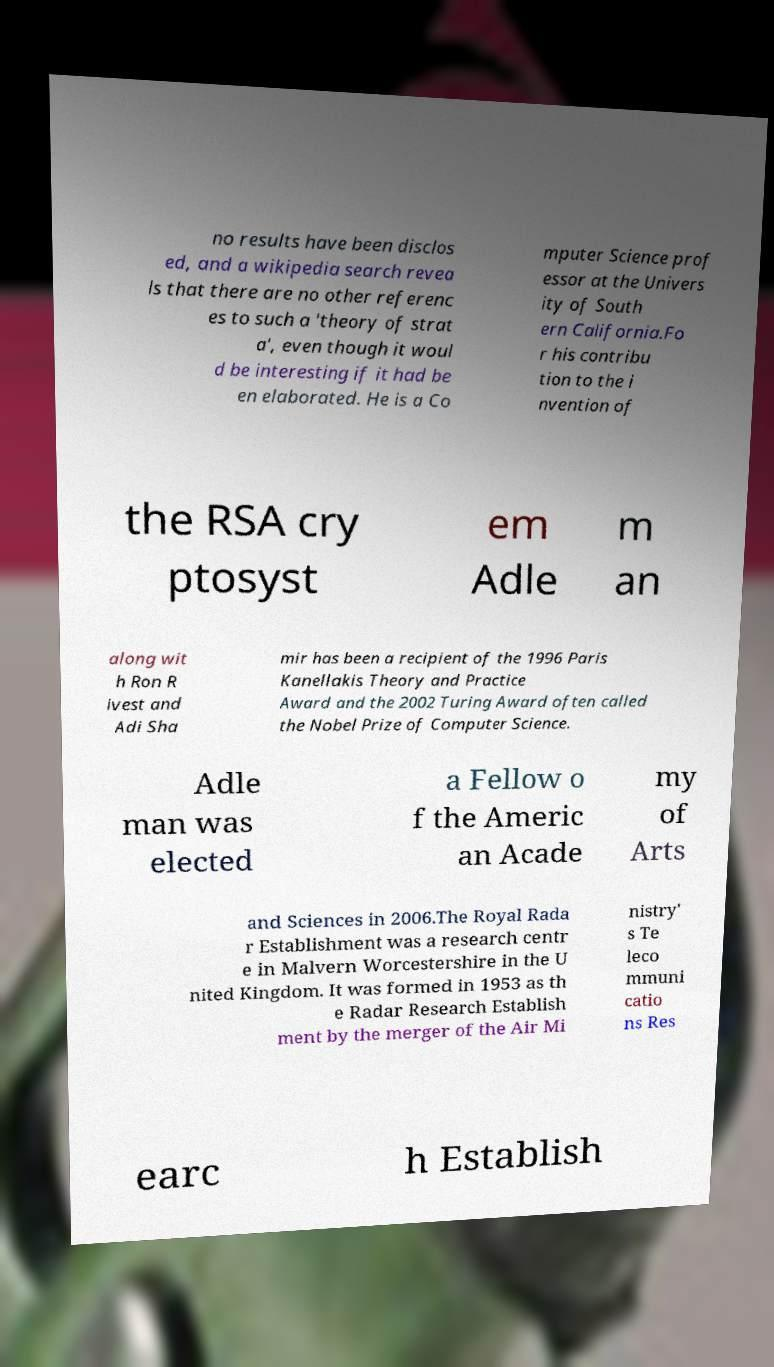Please identify and transcribe the text found in this image. no results have been disclos ed, and a wikipedia search revea ls that there are no other referenc es to such a 'theory of strat a', even though it woul d be interesting if it had be en elaborated. He is a Co mputer Science prof essor at the Univers ity of South ern California.Fo r his contribu tion to the i nvention of the RSA cry ptosyst em Adle m an along wit h Ron R ivest and Adi Sha mir has been a recipient of the 1996 Paris Kanellakis Theory and Practice Award and the 2002 Turing Award often called the Nobel Prize of Computer Science. Adle man was elected a Fellow o f the Americ an Acade my of Arts and Sciences in 2006.The Royal Rada r Establishment was a research centr e in Malvern Worcestershire in the U nited Kingdom. It was formed in 1953 as th e Radar Research Establish ment by the merger of the Air Mi nistry' s Te leco mmuni catio ns Res earc h Establish 